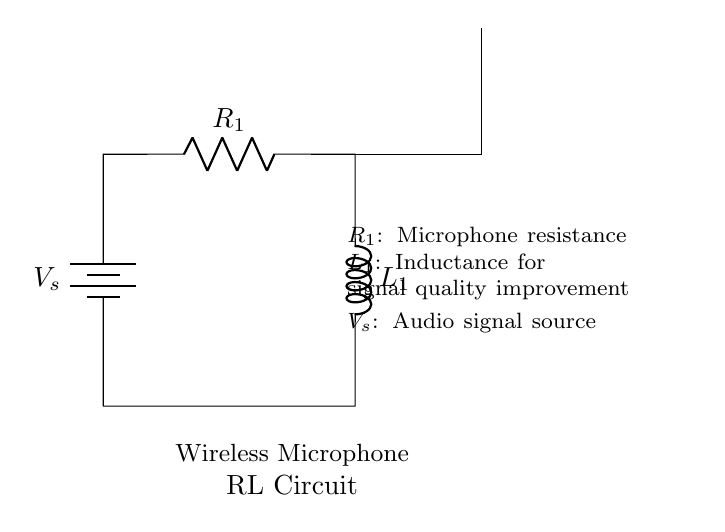What is the resistance in this circuit? The resistance in this circuit is represented by R1, which is indicated on the diagram.
Answer: R1 What component is used for signal quality improvement? The component that enhances signal quality in this circuit is the inductor, labeled as L1 in the diagram.
Answer: L1 What is the power source in this RL circuit? The power source for the circuit is indicated by the battery symbol, labeled as Vs.
Answer: Vs How many main components are in this RL circuit? The circuit contains three main components: a battery, a resistor, and an inductor.
Answer: Three What happens to the current in an RL circuit as the inductor charges? As the inductor charges, the current initially increases, but the rise is not instantaneous due to the inductor's tendency to oppose changes in current. Therefore, the current does not jump immediately to its maximum value and follows an exponential curve instead.
Answer: Increases How does the resistor affect the circuit's performance? The resistor, R1, controls the amount of current flowing through the circuit, limiting it to a safe level and affecting the overall power dissipation in the circuit. A higher resistance would lower the current, while a lower resistance would allow more current to flow, which can impact the performance of the microphone system.
Answer: Limits current What effect does increasing the inductance, L1, have on the circuit? Increasing the inductance, L1, will typically improve the circuit's ability to filter out high-frequency noise, thus enhancing the quality of the audio signal transmitted from the wireless microphone. This is because a larger inductance provides greater opposition to changes in current, allowing the circuit to smooth out fluctuations in the signal.
Answer: Improves signal quality 